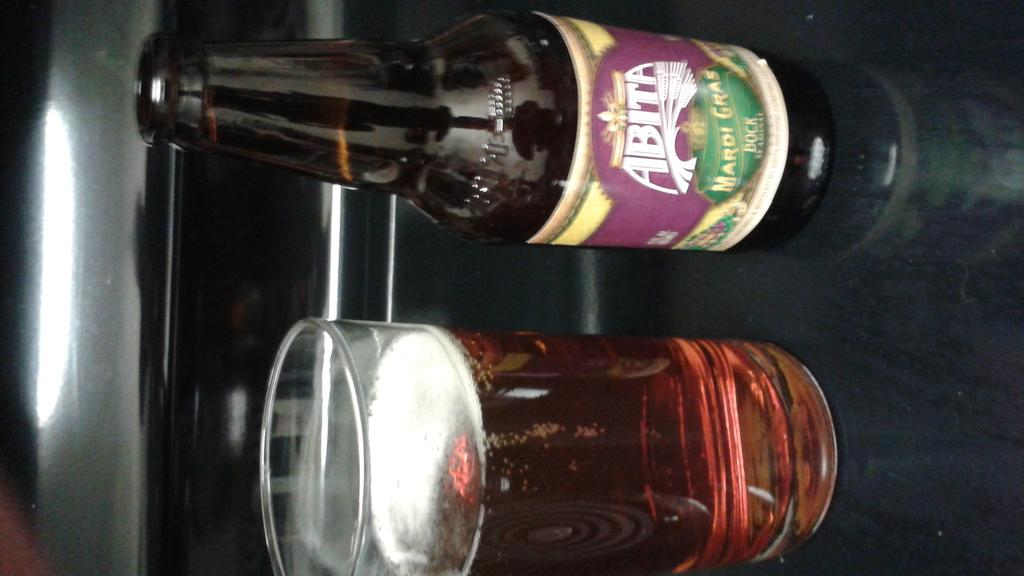What is the main object in the image? There is a wine bottle in the image. Where is the wine bottle located? The wine bottle is on a table. Is there any other wine-related object in the image? Yes, there is a wine glass on the wine bottle. What type of appliance is being used to open the wine bottle in the image? There is no appliance visible in the image, and the wine bottle is not being opened. 